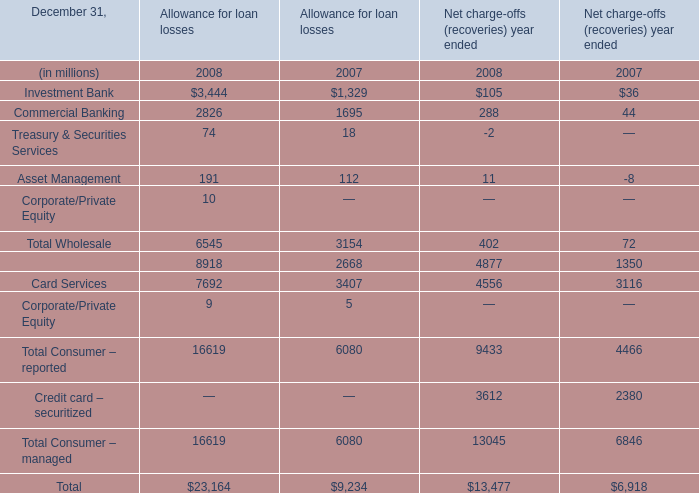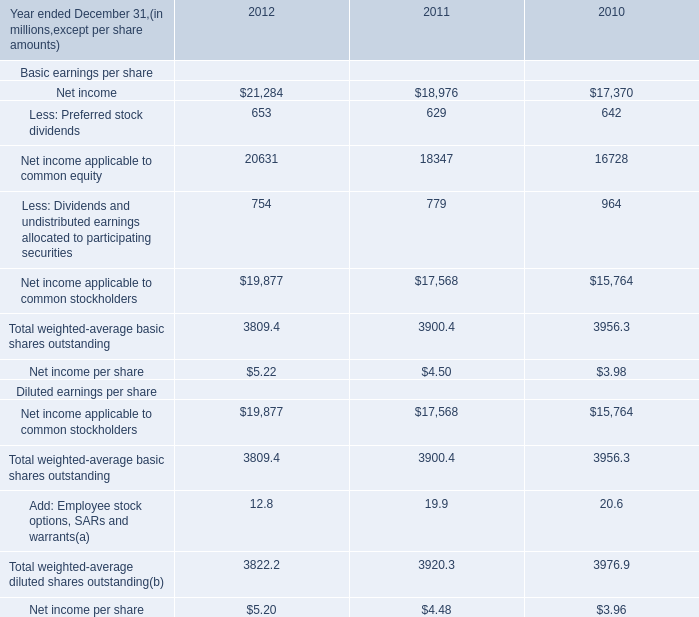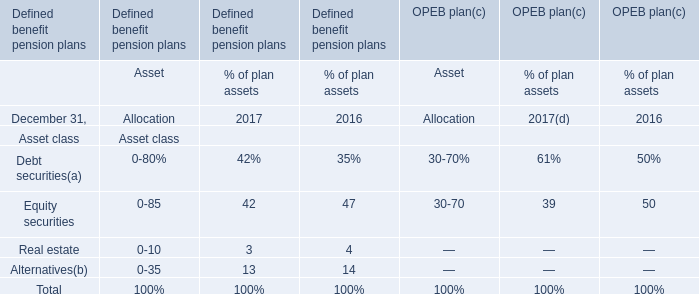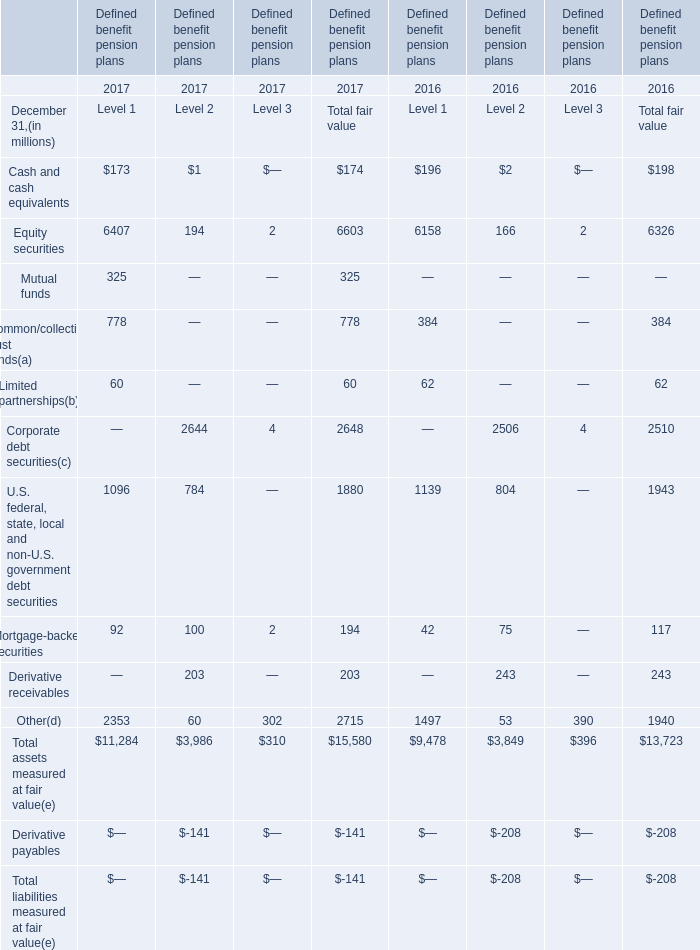What's the total amount of the Equity securities for Total fair value in the years where Cash and cash equivalents greater than 0 for Total fair value? (in million) 
Computations: (6603 + 6326)
Answer: 12929.0. 